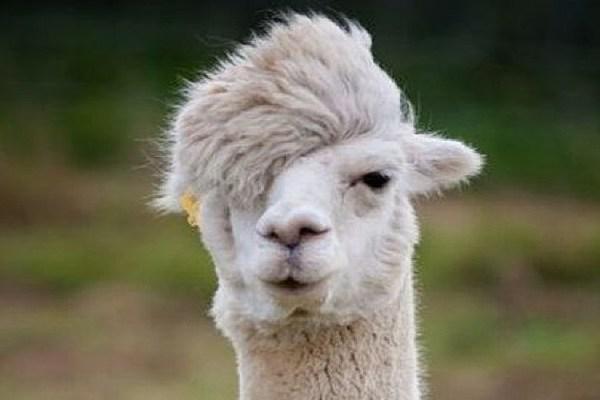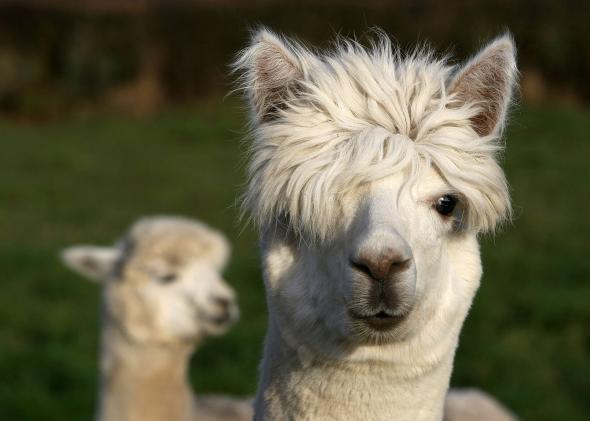The first image is the image on the left, the second image is the image on the right. Evaluate the accuracy of this statement regarding the images: "One image shows a forward-facing llama with projecting lower teeth, and the other image shows a forward-facing llama with woolly white hair on top of its head.". Is it true? Answer yes or no. No. The first image is the image on the left, the second image is the image on the right. For the images shown, is this caption "there is a llama  with it's mouth open wide showing it's tongue and teeth" true? Answer yes or no. No. 